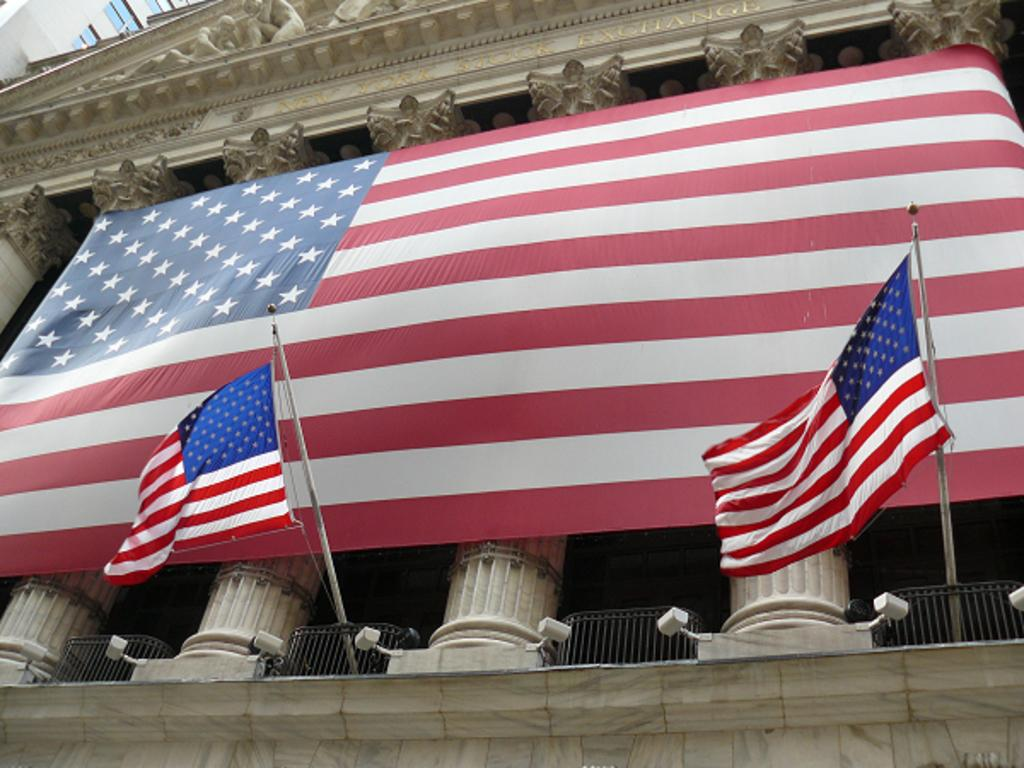What is attached to the wall in the image? There is a sculpture attached to the wall in the image. What else can be seen in the image besides the sculpture? There are flags, pillars, railing, and cameras attached to the wall in the image. Can you describe the architectural features in the image? A: The image features pillars and railing. What might be used for security purposes in the image? Cameras attached to the wall in the image might be used for security purposes. What type of oil is being used to develop the sculpture in the image? There is no mention of oil or development in the image; it features a sculpture, flags, pillars, railing, and cameras. 